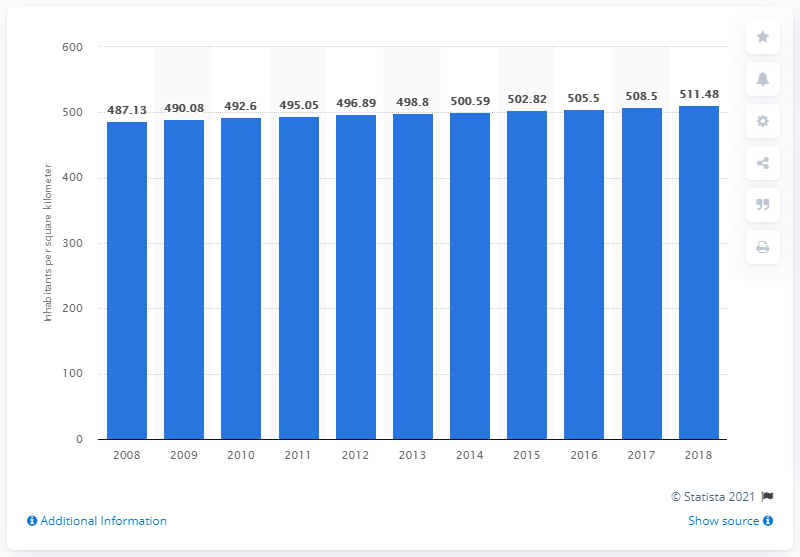Highlight a few significant elements in this photo. In 2018, the population density of the Netherlands was approximately 511.48 people per square kilometer. 